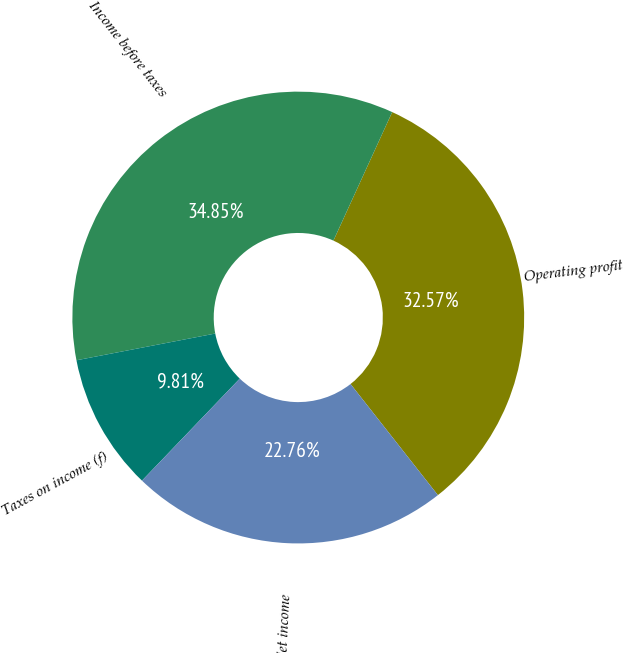Convert chart to OTSL. <chart><loc_0><loc_0><loc_500><loc_500><pie_chart><fcel>Operating profit<fcel>Income before taxes<fcel>Taxes on income (f)<fcel>Net income<nl><fcel>32.57%<fcel>34.85%<fcel>9.81%<fcel>22.76%<nl></chart> 